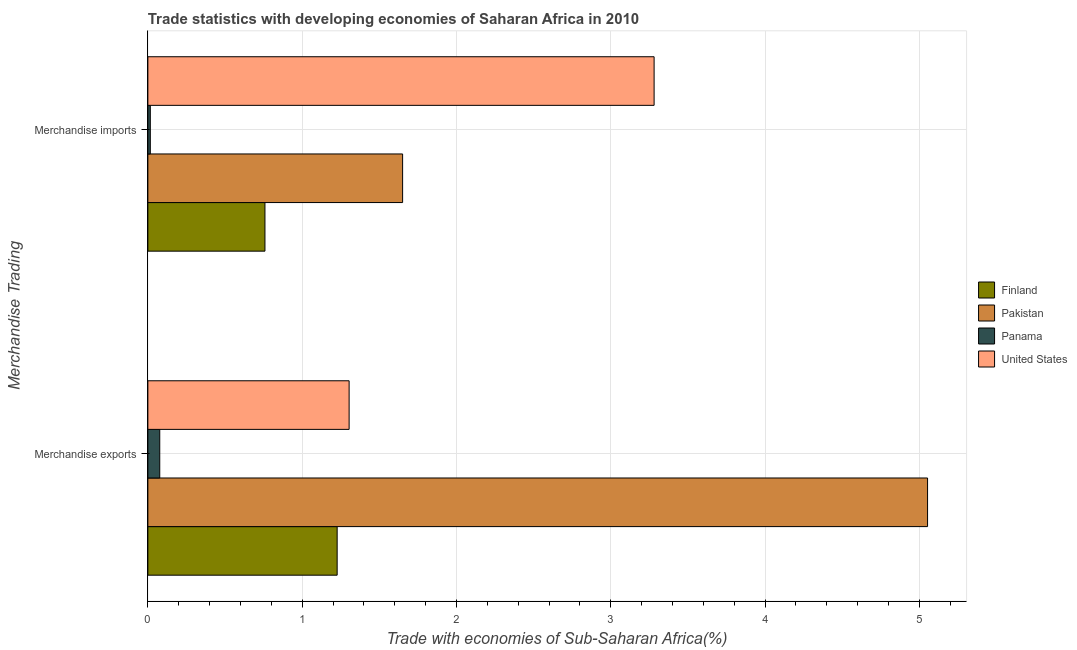How many groups of bars are there?
Your response must be concise. 2. What is the label of the 2nd group of bars from the top?
Provide a short and direct response. Merchandise exports. What is the merchandise imports in Pakistan?
Keep it short and to the point. 1.65. Across all countries, what is the maximum merchandise imports?
Offer a very short reply. 3.28. Across all countries, what is the minimum merchandise exports?
Keep it short and to the point. 0.08. In which country was the merchandise exports minimum?
Offer a very short reply. Panama. What is the total merchandise exports in the graph?
Ensure brevity in your answer.  7.66. What is the difference between the merchandise exports in Finland and that in Panama?
Offer a terse response. 1.15. What is the difference between the merchandise exports in Panama and the merchandise imports in Pakistan?
Provide a succinct answer. -1.57. What is the average merchandise imports per country?
Make the answer very short. 1.43. What is the difference between the merchandise exports and merchandise imports in Finland?
Provide a short and direct response. 0.47. What is the ratio of the merchandise exports in United States to that in Panama?
Offer a terse response. 16.93. Is the merchandise imports in Finland less than that in Panama?
Offer a very short reply. No. In how many countries, is the merchandise exports greater than the average merchandise exports taken over all countries?
Your answer should be compact. 1. What does the 4th bar from the top in Merchandise imports represents?
Ensure brevity in your answer.  Finland. How many bars are there?
Keep it short and to the point. 8. What is the difference between two consecutive major ticks on the X-axis?
Your answer should be very brief. 1. Does the graph contain any zero values?
Offer a very short reply. No. Does the graph contain grids?
Provide a short and direct response. Yes. How are the legend labels stacked?
Offer a terse response. Vertical. What is the title of the graph?
Offer a terse response. Trade statistics with developing economies of Saharan Africa in 2010. Does "Tajikistan" appear as one of the legend labels in the graph?
Keep it short and to the point. No. What is the label or title of the X-axis?
Your answer should be very brief. Trade with economies of Sub-Saharan Africa(%). What is the label or title of the Y-axis?
Provide a short and direct response. Merchandise Trading. What is the Trade with economies of Sub-Saharan Africa(%) of Finland in Merchandise exports?
Your response must be concise. 1.23. What is the Trade with economies of Sub-Saharan Africa(%) of Pakistan in Merchandise exports?
Your answer should be very brief. 5.05. What is the Trade with economies of Sub-Saharan Africa(%) of Panama in Merchandise exports?
Your answer should be compact. 0.08. What is the Trade with economies of Sub-Saharan Africa(%) of United States in Merchandise exports?
Your answer should be very brief. 1.3. What is the Trade with economies of Sub-Saharan Africa(%) in Finland in Merchandise imports?
Provide a short and direct response. 0.76. What is the Trade with economies of Sub-Saharan Africa(%) in Pakistan in Merchandise imports?
Ensure brevity in your answer.  1.65. What is the Trade with economies of Sub-Saharan Africa(%) in Panama in Merchandise imports?
Your response must be concise. 0.02. What is the Trade with economies of Sub-Saharan Africa(%) of United States in Merchandise imports?
Your answer should be compact. 3.28. Across all Merchandise Trading, what is the maximum Trade with economies of Sub-Saharan Africa(%) of Finland?
Offer a very short reply. 1.23. Across all Merchandise Trading, what is the maximum Trade with economies of Sub-Saharan Africa(%) of Pakistan?
Ensure brevity in your answer.  5.05. Across all Merchandise Trading, what is the maximum Trade with economies of Sub-Saharan Africa(%) of Panama?
Offer a terse response. 0.08. Across all Merchandise Trading, what is the maximum Trade with economies of Sub-Saharan Africa(%) in United States?
Ensure brevity in your answer.  3.28. Across all Merchandise Trading, what is the minimum Trade with economies of Sub-Saharan Africa(%) of Finland?
Give a very brief answer. 0.76. Across all Merchandise Trading, what is the minimum Trade with economies of Sub-Saharan Africa(%) in Pakistan?
Make the answer very short. 1.65. Across all Merchandise Trading, what is the minimum Trade with economies of Sub-Saharan Africa(%) of Panama?
Provide a succinct answer. 0.02. Across all Merchandise Trading, what is the minimum Trade with economies of Sub-Saharan Africa(%) of United States?
Offer a terse response. 1.3. What is the total Trade with economies of Sub-Saharan Africa(%) in Finland in the graph?
Provide a succinct answer. 1.99. What is the total Trade with economies of Sub-Saharan Africa(%) in Pakistan in the graph?
Your response must be concise. 6.7. What is the total Trade with economies of Sub-Saharan Africa(%) in Panama in the graph?
Offer a very short reply. 0.09. What is the total Trade with economies of Sub-Saharan Africa(%) in United States in the graph?
Your response must be concise. 4.58. What is the difference between the Trade with economies of Sub-Saharan Africa(%) in Finland in Merchandise exports and that in Merchandise imports?
Give a very brief answer. 0.47. What is the difference between the Trade with economies of Sub-Saharan Africa(%) of Pakistan in Merchandise exports and that in Merchandise imports?
Provide a succinct answer. 3.4. What is the difference between the Trade with economies of Sub-Saharan Africa(%) in Panama in Merchandise exports and that in Merchandise imports?
Ensure brevity in your answer.  0.06. What is the difference between the Trade with economies of Sub-Saharan Africa(%) in United States in Merchandise exports and that in Merchandise imports?
Keep it short and to the point. -1.98. What is the difference between the Trade with economies of Sub-Saharan Africa(%) of Finland in Merchandise exports and the Trade with economies of Sub-Saharan Africa(%) of Pakistan in Merchandise imports?
Your answer should be very brief. -0.42. What is the difference between the Trade with economies of Sub-Saharan Africa(%) in Finland in Merchandise exports and the Trade with economies of Sub-Saharan Africa(%) in Panama in Merchandise imports?
Keep it short and to the point. 1.21. What is the difference between the Trade with economies of Sub-Saharan Africa(%) in Finland in Merchandise exports and the Trade with economies of Sub-Saharan Africa(%) in United States in Merchandise imports?
Provide a succinct answer. -2.05. What is the difference between the Trade with economies of Sub-Saharan Africa(%) of Pakistan in Merchandise exports and the Trade with economies of Sub-Saharan Africa(%) of Panama in Merchandise imports?
Provide a succinct answer. 5.04. What is the difference between the Trade with economies of Sub-Saharan Africa(%) of Pakistan in Merchandise exports and the Trade with economies of Sub-Saharan Africa(%) of United States in Merchandise imports?
Offer a very short reply. 1.77. What is the difference between the Trade with economies of Sub-Saharan Africa(%) in Panama in Merchandise exports and the Trade with economies of Sub-Saharan Africa(%) in United States in Merchandise imports?
Give a very brief answer. -3.2. What is the average Trade with economies of Sub-Saharan Africa(%) in Pakistan per Merchandise Trading?
Provide a succinct answer. 3.35. What is the average Trade with economies of Sub-Saharan Africa(%) in Panama per Merchandise Trading?
Your response must be concise. 0.05. What is the average Trade with economies of Sub-Saharan Africa(%) in United States per Merchandise Trading?
Provide a succinct answer. 2.29. What is the difference between the Trade with economies of Sub-Saharan Africa(%) in Finland and Trade with economies of Sub-Saharan Africa(%) in Pakistan in Merchandise exports?
Provide a succinct answer. -3.83. What is the difference between the Trade with economies of Sub-Saharan Africa(%) in Finland and Trade with economies of Sub-Saharan Africa(%) in Panama in Merchandise exports?
Offer a very short reply. 1.15. What is the difference between the Trade with economies of Sub-Saharan Africa(%) in Finland and Trade with economies of Sub-Saharan Africa(%) in United States in Merchandise exports?
Provide a succinct answer. -0.08. What is the difference between the Trade with economies of Sub-Saharan Africa(%) of Pakistan and Trade with economies of Sub-Saharan Africa(%) of Panama in Merchandise exports?
Offer a terse response. 4.98. What is the difference between the Trade with economies of Sub-Saharan Africa(%) in Pakistan and Trade with economies of Sub-Saharan Africa(%) in United States in Merchandise exports?
Make the answer very short. 3.75. What is the difference between the Trade with economies of Sub-Saharan Africa(%) of Panama and Trade with economies of Sub-Saharan Africa(%) of United States in Merchandise exports?
Your response must be concise. -1.23. What is the difference between the Trade with economies of Sub-Saharan Africa(%) of Finland and Trade with economies of Sub-Saharan Africa(%) of Pakistan in Merchandise imports?
Offer a very short reply. -0.89. What is the difference between the Trade with economies of Sub-Saharan Africa(%) of Finland and Trade with economies of Sub-Saharan Africa(%) of Panama in Merchandise imports?
Keep it short and to the point. 0.74. What is the difference between the Trade with economies of Sub-Saharan Africa(%) of Finland and Trade with economies of Sub-Saharan Africa(%) of United States in Merchandise imports?
Give a very brief answer. -2.52. What is the difference between the Trade with economies of Sub-Saharan Africa(%) of Pakistan and Trade with economies of Sub-Saharan Africa(%) of Panama in Merchandise imports?
Ensure brevity in your answer.  1.64. What is the difference between the Trade with economies of Sub-Saharan Africa(%) in Pakistan and Trade with economies of Sub-Saharan Africa(%) in United States in Merchandise imports?
Provide a short and direct response. -1.63. What is the difference between the Trade with economies of Sub-Saharan Africa(%) of Panama and Trade with economies of Sub-Saharan Africa(%) of United States in Merchandise imports?
Offer a very short reply. -3.26. What is the ratio of the Trade with economies of Sub-Saharan Africa(%) of Finland in Merchandise exports to that in Merchandise imports?
Ensure brevity in your answer.  1.62. What is the ratio of the Trade with economies of Sub-Saharan Africa(%) of Pakistan in Merchandise exports to that in Merchandise imports?
Ensure brevity in your answer.  3.06. What is the ratio of the Trade with economies of Sub-Saharan Africa(%) in Panama in Merchandise exports to that in Merchandise imports?
Provide a short and direct response. 4.87. What is the ratio of the Trade with economies of Sub-Saharan Africa(%) of United States in Merchandise exports to that in Merchandise imports?
Keep it short and to the point. 0.4. What is the difference between the highest and the second highest Trade with economies of Sub-Saharan Africa(%) in Finland?
Offer a terse response. 0.47. What is the difference between the highest and the second highest Trade with economies of Sub-Saharan Africa(%) of Pakistan?
Give a very brief answer. 3.4. What is the difference between the highest and the second highest Trade with economies of Sub-Saharan Africa(%) in Panama?
Offer a terse response. 0.06. What is the difference between the highest and the second highest Trade with economies of Sub-Saharan Africa(%) of United States?
Your response must be concise. 1.98. What is the difference between the highest and the lowest Trade with economies of Sub-Saharan Africa(%) in Finland?
Provide a short and direct response. 0.47. What is the difference between the highest and the lowest Trade with economies of Sub-Saharan Africa(%) in Pakistan?
Keep it short and to the point. 3.4. What is the difference between the highest and the lowest Trade with economies of Sub-Saharan Africa(%) of Panama?
Make the answer very short. 0.06. What is the difference between the highest and the lowest Trade with economies of Sub-Saharan Africa(%) of United States?
Ensure brevity in your answer.  1.98. 